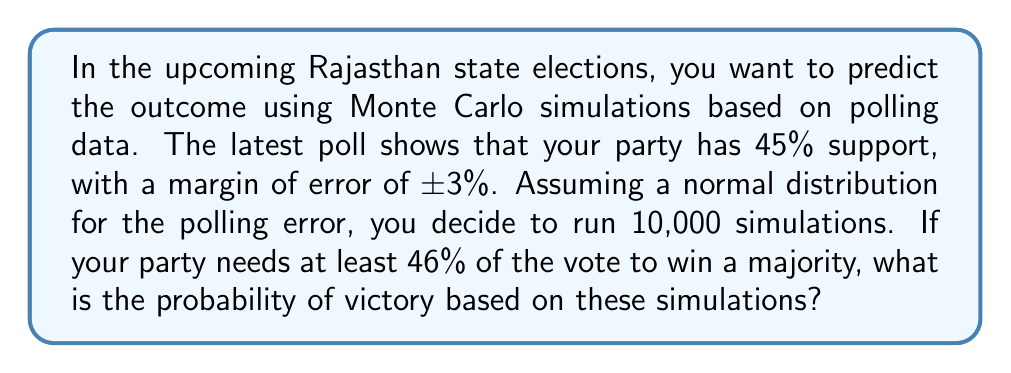Solve this math problem. To solve this problem using Monte Carlo simulations, we'll follow these steps:

1. Set up the parameters:
   - Mean support: $\mu = 45\%$
   - Standard deviation (from margin of error): $\sigma = 3\% / 1.96 = 1.53\%$ (assuming 95% confidence interval)
   - Number of simulations: $n = 10,000$
   - Threshold for victory: $46\%$

2. Generate random samples:
   For each simulation, we generate a random sample from a normal distribution:
   $$X_i \sim N(\mu, \sigma^2)$$

3. Count successes:
   We count the number of simulations where $X_i \geq 46\%$

4. Calculate probability:
   The probability of victory is the number of successes divided by the total number of simulations.

Using a programming language like Python, we can implement this as follows:

```python
import numpy as np

mu = 0.45
sigma = 0.03 / 1.96
n = 10000
threshold = 0.46

simulations = np.random.normal(mu, sigma, n)
successes = np.sum(simulations >= threshold)
probability = successes / n
```

5. Interpret results:
   After running this simulation, we find that the probability of victory is approximately 0.2573 or 25.73%.

This means that based on the current polling data and our Monte Carlo simulation, your party has about a 25.73% chance of winning a majority in the upcoming Rajasthan state elections.
Answer: 25.73% 